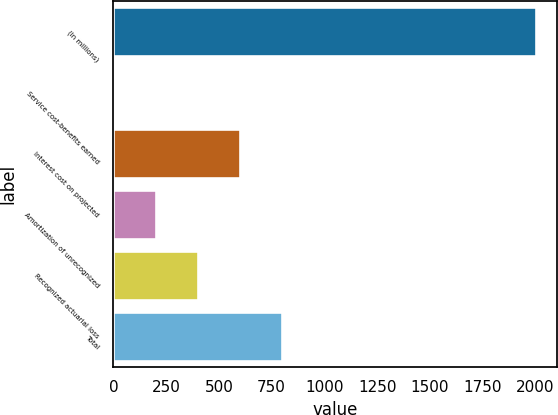Convert chart to OTSL. <chart><loc_0><loc_0><loc_500><loc_500><bar_chart><fcel>(In millions)<fcel>Service cost-benefits earned<fcel>Interest cost on projected<fcel>Amortization of unrecognized<fcel>Recognized actuarial loss<fcel>Total<nl><fcel>2001<fcel>0.7<fcel>600.79<fcel>200.73<fcel>400.76<fcel>800.82<nl></chart> 